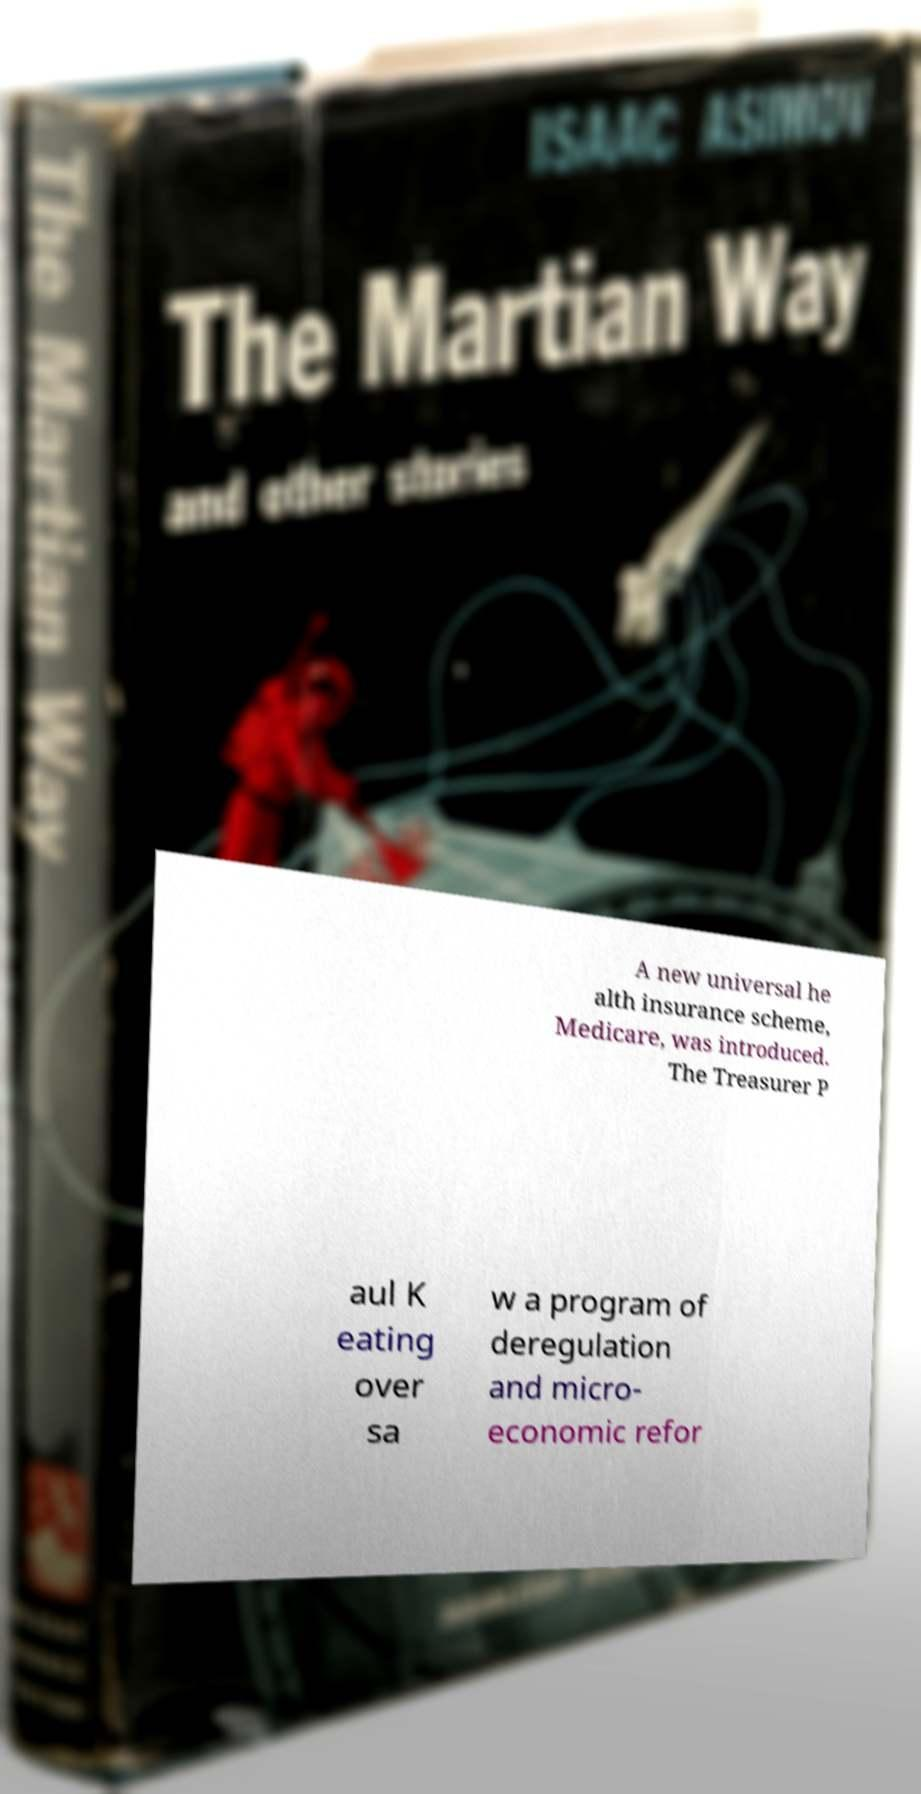There's text embedded in this image that I need extracted. Can you transcribe it verbatim? A new universal he alth insurance scheme, Medicare, was introduced. The Treasurer P aul K eating over sa w a program of deregulation and micro- economic refor 